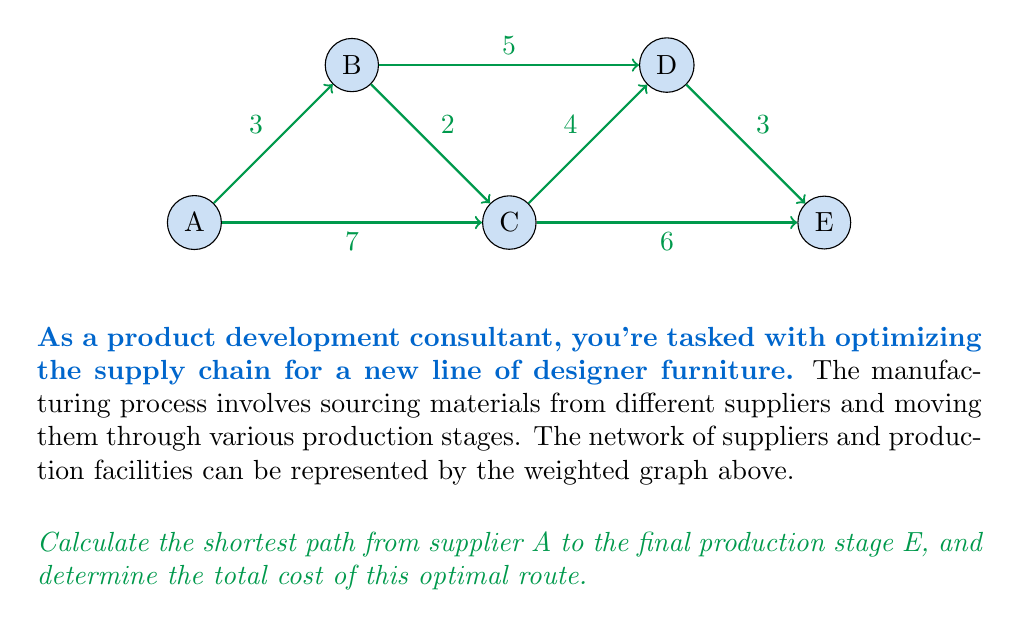Teach me how to tackle this problem. To solve this problem, we'll use Dijkstra's algorithm to find the shortest path from A to E in the weighted graph.

Step 1: Initialize distances
- Set distance to A as 0
- Set distances to all other nodes as infinity

Step 2: Visit node A
- Update distances:
  B: min(∞, 0 + 3) = 3
  C: min(∞, 0 + 7) = 7

Step 3: Visit node B (closest unvisited node)
- Update distances:
  C: min(7, 3 + 2) = 5
  D: min(∞, 3 + 5) = 8

Step 4: Visit node C
- Update distances:
  D: min(8, 5 + 4) = 8 (no change)
  E: min(∞, 5 + 6) = 11

Step 5: Visit node D
- Update distances:
  E: min(11, 8 + 3) = 11 (no change)

Step 6: Visit node E
- All nodes visited, algorithm terminates

The shortest path is A → B → C → E with a total cost of 11.

To verify:
A → B: 3
B → C: 2
C → E: 6
Total: 3 + 2 + 6 = 11

This path is indeed shorter than other possible routes:
A → C → E: 7 + 6 = 13
A → B → D → E: 3 + 5 + 3 = 11 (same cost but longer path)
A → C → D → E: 7 + 4 + 3 = 14
Answer: A → B → C → E, cost = 11 